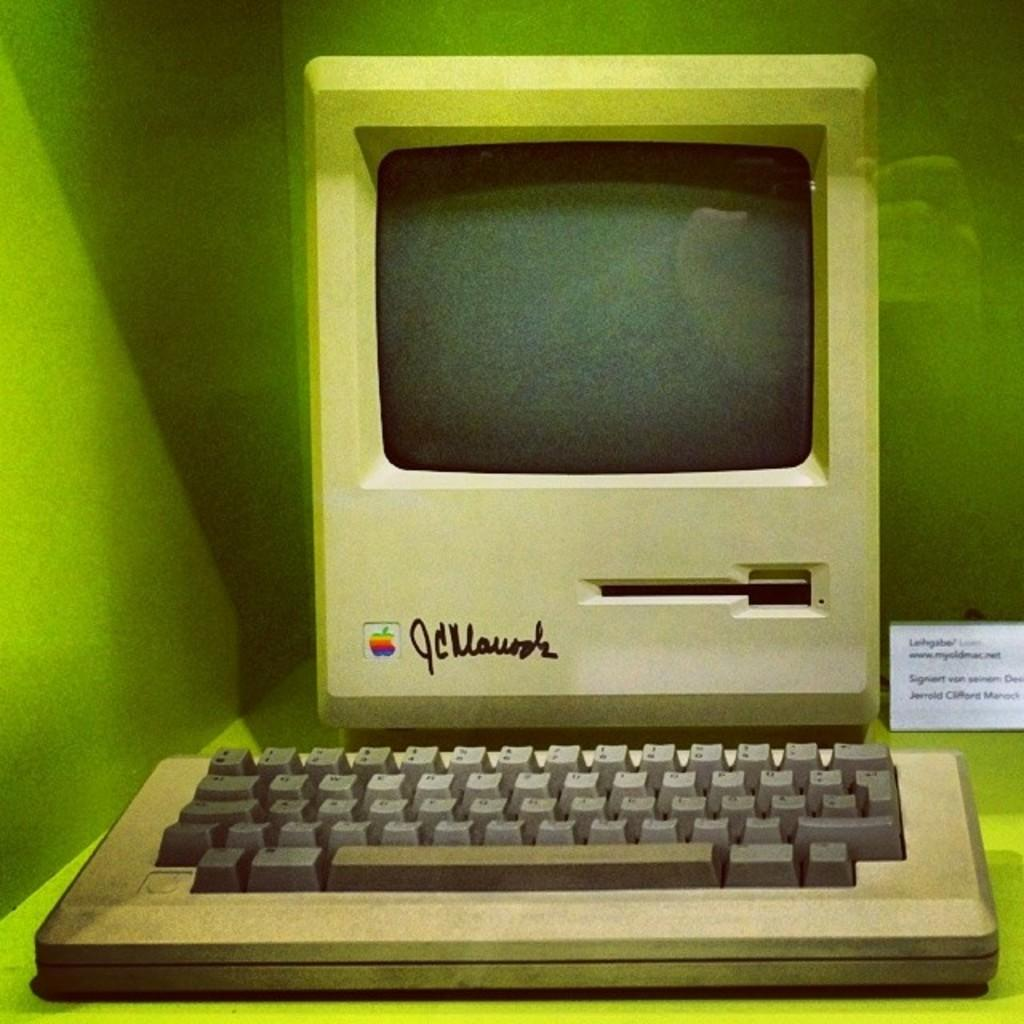<image>
Share a concise interpretation of the image provided. An old apple desktop computer on display with a signature to the right of the Apple logo. 